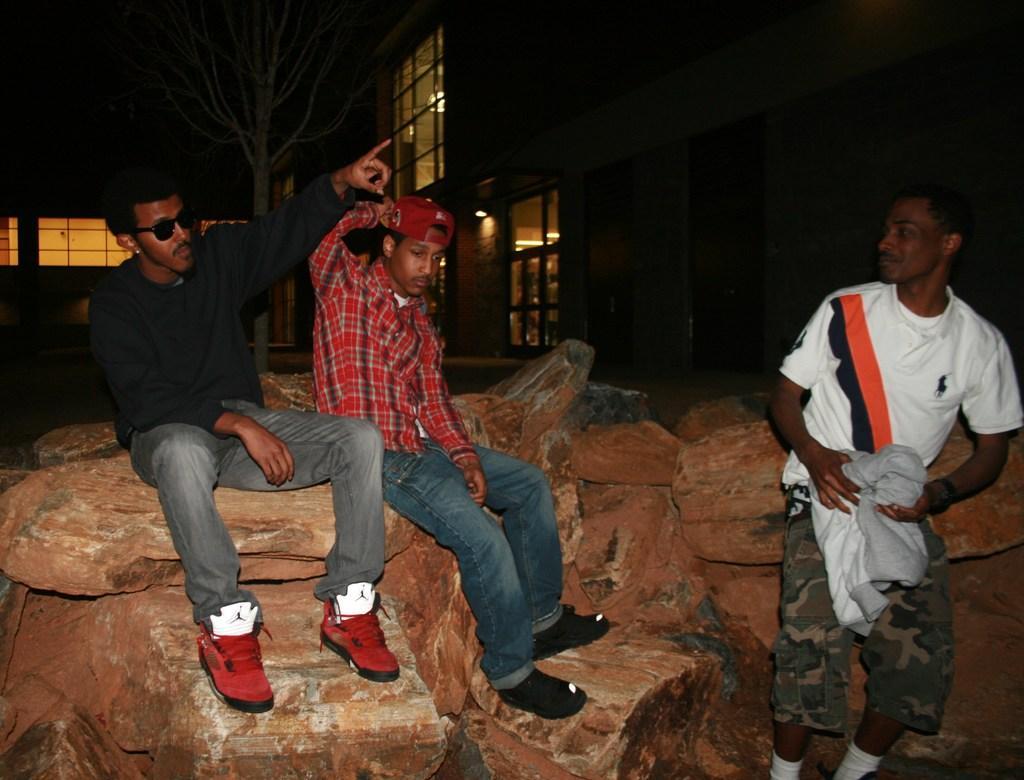Please provide a concise description of this image. In this image I can see few people sitting on stones. In the background there is a building. 